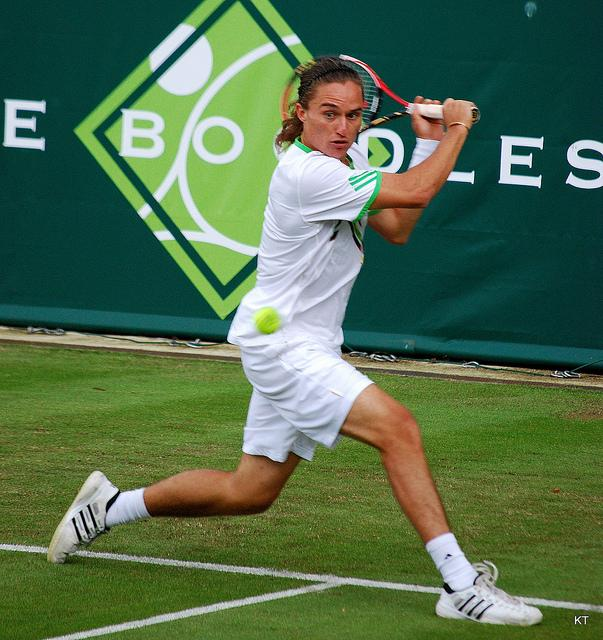What is the color of tennis ball used in earlier days?

Choices:
A) red
B) white
C) green
D) yellow yellow 